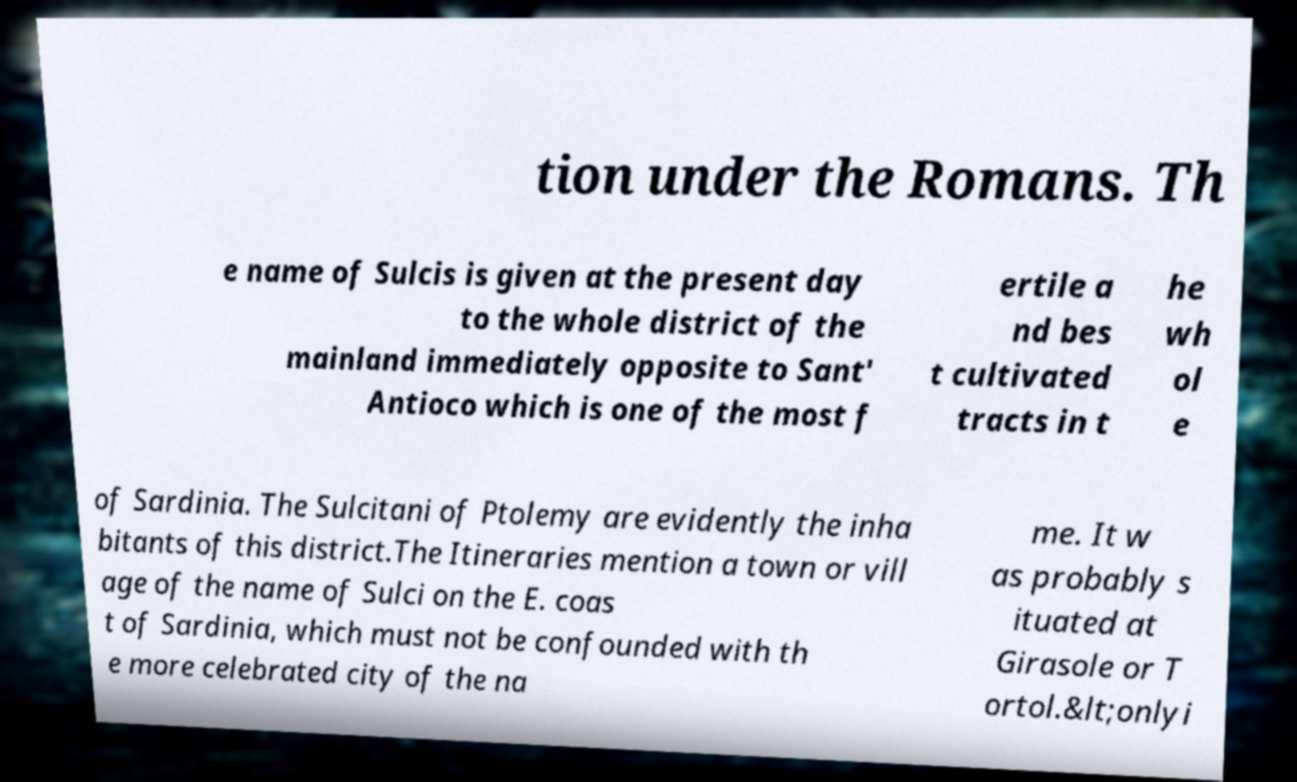Could you assist in decoding the text presented in this image and type it out clearly? tion under the Romans. Th e name of Sulcis is given at the present day to the whole district of the mainland immediately opposite to Sant' Antioco which is one of the most f ertile a nd bes t cultivated tracts in t he wh ol e of Sardinia. The Sulcitani of Ptolemy are evidently the inha bitants of this district.The Itineraries mention a town or vill age of the name of Sulci on the E. coas t of Sardinia, which must not be confounded with th e more celebrated city of the na me. It w as probably s ituated at Girasole or T ortol.&lt;onlyi 